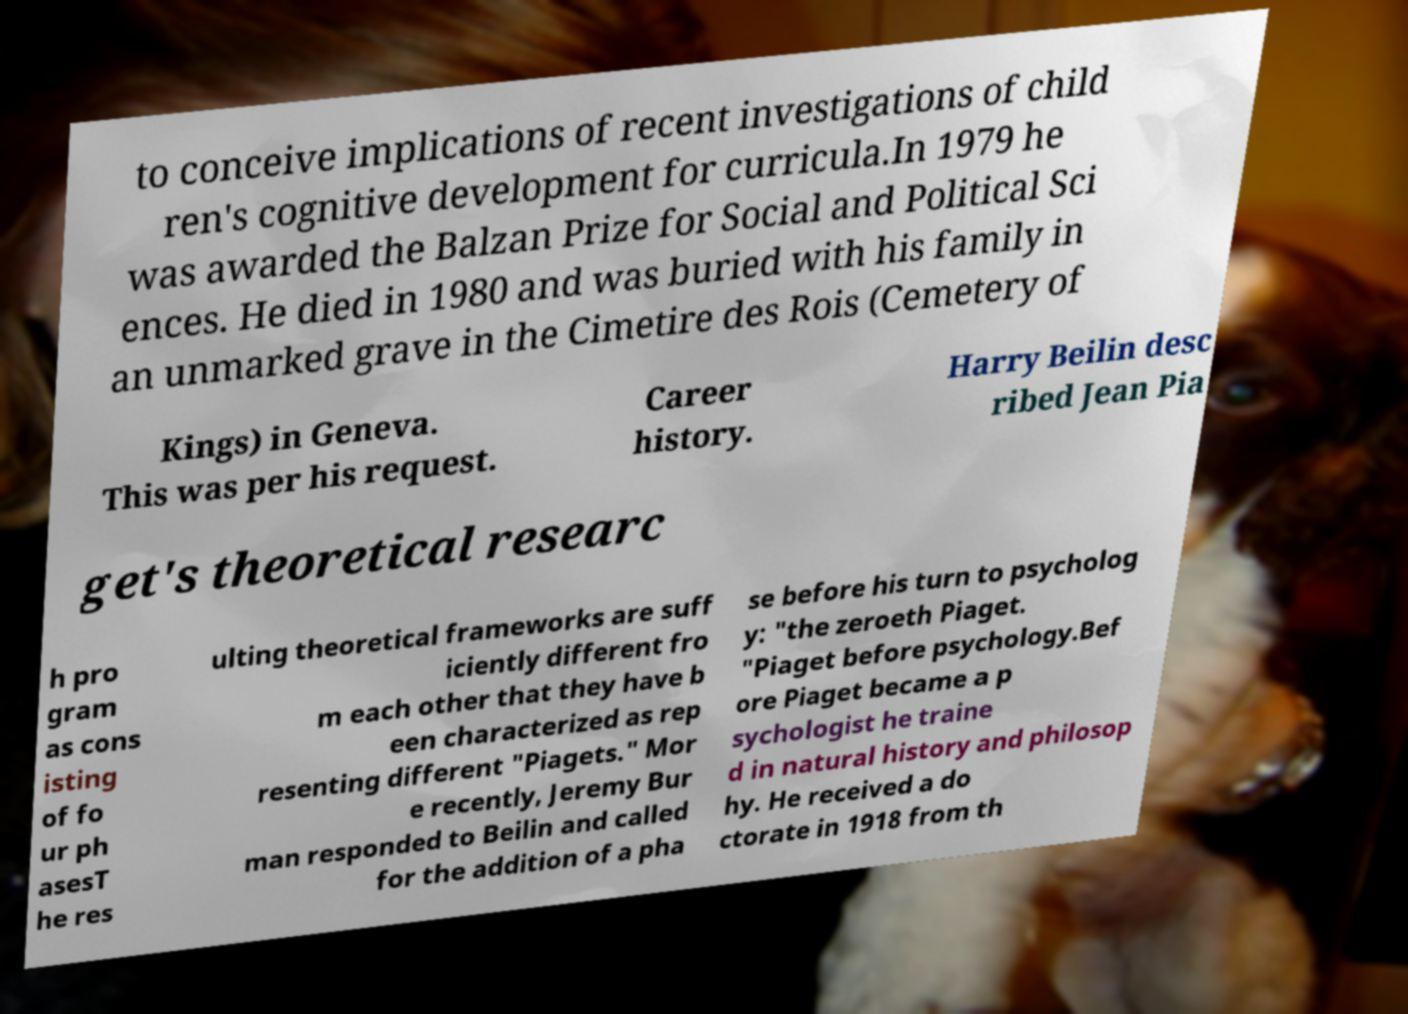There's text embedded in this image that I need extracted. Can you transcribe it verbatim? to conceive implications of recent investigations of child ren's cognitive development for curricula.In 1979 he was awarded the Balzan Prize for Social and Political Sci ences. He died in 1980 and was buried with his family in an unmarked grave in the Cimetire des Rois (Cemetery of Kings) in Geneva. This was per his request. Career history. Harry Beilin desc ribed Jean Pia get's theoretical researc h pro gram as cons isting of fo ur ph asesT he res ulting theoretical frameworks are suff iciently different fro m each other that they have b een characterized as rep resenting different "Piagets." Mor e recently, Jeremy Bur man responded to Beilin and called for the addition of a pha se before his turn to psycholog y: "the zeroeth Piaget. "Piaget before psychology.Bef ore Piaget became a p sychologist he traine d in natural history and philosop hy. He received a do ctorate in 1918 from th 